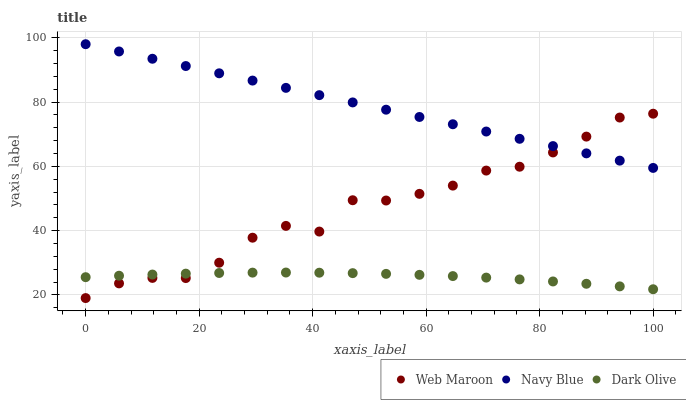Does Dark Olive have the minimum area under the curve?
Answer yes or no. Yes. Does Navy Blue have the maximum area under the curve?
Answer yes or no. Yes. Does Web Maroon have the minimum area under the curve?
Answer yes or no. No. Does Web Maroon have the maximum area under the curve?
Answer yes or no. No. Is Navy Blue the smoothest?
Answer yes or no. Yes. Is Web Maroon the roughest?
Answer yes or no. Yes. Is Dark Olive the smoothest?
Answer yes or no. No. Is Dark Olive the roughest?
Answer yes or no. No. Does Web Maroon have the lowest value?
Answer yes or no. Yes. Does Dark Olive have the lowest value?
Answer yes or no. No. Does Navy Blue have the highest value?
Answer yes or no. Yes. Does Web Maroon have the highest value?
Answer yes or no. No. Is Dark Olive less than Navy Blue?
Answer yes or no. Yes. Is Navy Blue greater than Dark Olive?
Answer yes or no. Yes. Does Dark Olive intersect Web Maroon?
Answer yes or no. Yes. Is Dark Olive less than Web Maroon?
Answer yes or no. No. Is Dark Olive greater than Web Maroon?
Answer yes or no. No. Does Dark Olive intersect Navy Blue?
Answer yes or no. No. 